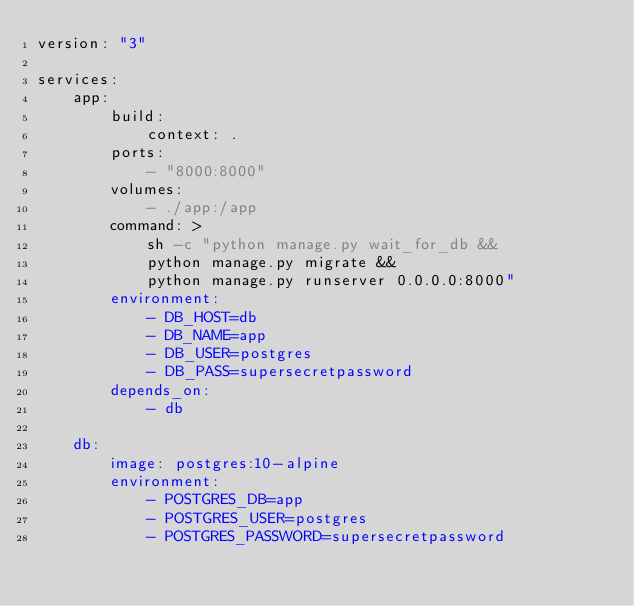<code> <loc_0><loc_0><loc_500><loc_500><_YAML_>version: "3"

services:
    app:
        build:
            context: .
        ports:
            - "8000:8000"
        volumes:
            - ./app:/app
        command: >
            sh -c "python manage.py wait_for_db &&
            python manage.py migrate &&
            python manage.py runserver 0.0.0.0:8000"
        environment:
            - DB_HOST=db
            - DB_NAME=app
            - DB_USER=postgres
            - DB_PASS=supersecretpassword
        depends_on: 
            - db

    db: 
        image: postgres:10-alpine
        environment:
            - POSTGRES_DB=app
            - POSTGRES_USER=postgres
            - POSTGRES_PASSWORD=supersecretpassword</code> 